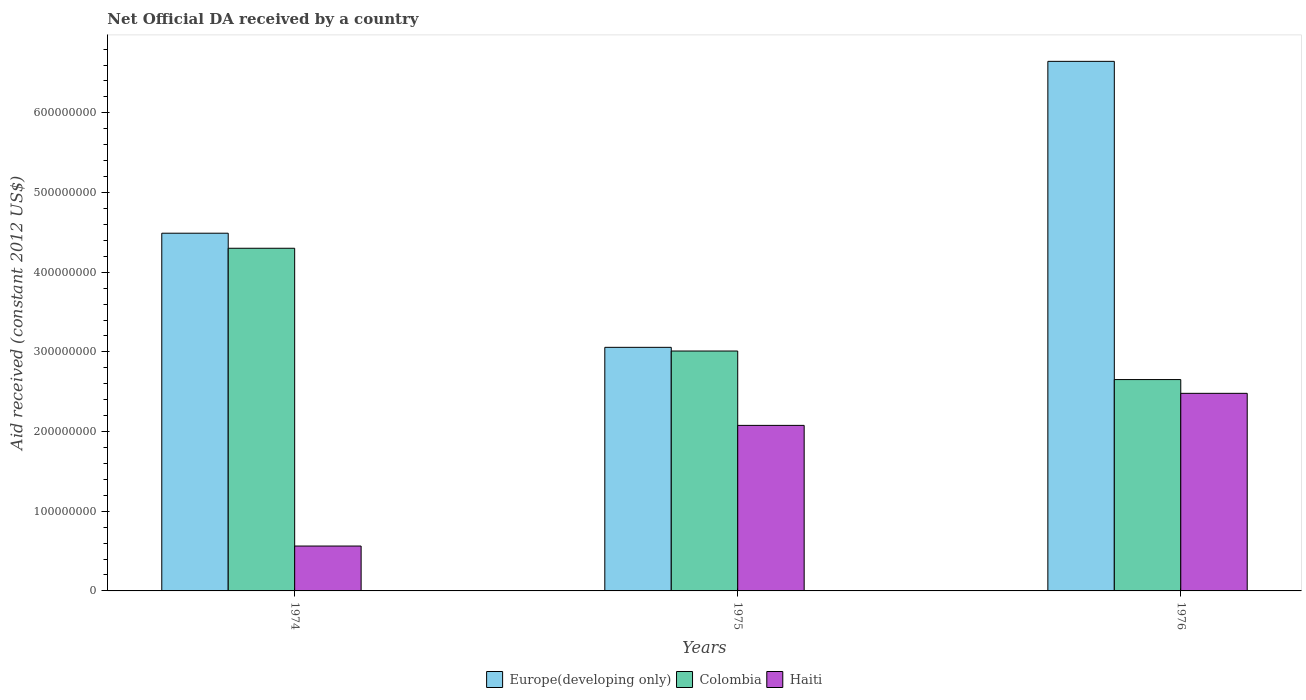Are the number of bars per tick equal to the number of legend labels?
Your answer should be compact. Yes. How many bars are there on the 3rd tick from the left?
Provide a short and direct response. 3. What is the label of the 1st group of bars from the left?
Make the answer very short. 1974. What is the net official development assistance aid received in Haiti in 1974?
Keep it short and to the point. 5.63e+07. Across all years, what is the maximum net official development assistance aid received in Europe(developing only)?
Your answer should be compact. 6.65e+08. Across all years, what is the minimum net official development assistance aid received in Europe(developing only)?
Give a very brief answer. 3.06e+08. In which year was the net official development assistance aid received in Haiti maximum?
Make the answer very short. 1976. In which year was the net official development assistance aid received in Haiti minimum?
Provide a short and direct response. 1974. What is the total net official development assistance aid received in Colombia in the graph?
Provide a short and direct response. 9.96e+08. What is the difference between the net official development assistance aid received in Colombia in 1975 and that in 1976?
Keep it short and to the point. 3.58e+07. What is the difference between the net official development assistance aid received in Europe(developing only) in 1975 and the net official development assistance aid received in Haiti in 1976?
Provide a succinct answer. 5.77e+07. What is the average net official development assistance aid received in Europe(developing only) per year?
Make the answer very short. 4.73e+08. In the year 1974, what is the difference between the net official development assistance aid received in Europe(developing only) and net official development assistance aid received in Haiti?
Your response must be concise. 3.93e+08. In how many years, is the net official development assistance aid received in Colombia greater than 180000000 US$?
Offer a very short reply. 3. What is the ratio of the net official development assistance aid received in Colombia in 1974 to that in 1976?
Make the answer very short. 1.62. Is the net official development assistance aid received in Haiti in 1974 less than that in 1976?
Offer a very short reply. Yes. What is the difference between the highest and the second highest net official development assistance aid received in Haiti?
Offer a terse response. 4.02e+07. What is the difference between the highest and the lowest net official development assistance aid received in Haiti?
Provide a short and direct response. 1.92e+08. Is the sum of the net official development assistance aid received in Haiti in 1974 and 1976 greater than the maximum net official development assistance aid received in Europe(developing only) across all years?
Offer a very short reply. No. What does the 3rd bar from the left in 1974 represents?
Give a very brief answer. Haiti. What does the 2nd bar from the right in 1975 represents?
Ensure brevity in your answer.  Colombia. Is it the case that in every year, the sum of the net official development assistance aid received in Europe(developing only) and net official development assistance aid received in Haiti is greater than the net official development assistance aid received in Colombia?
Provide a succinct answer. Yes. How many years are there in the graph?
Ensure brevity in your answer.  3. Does the graph contain any zero values?
Make the answer very short. No. How many legend labels are there?
Offer a terse response. 3. What is the title of the graph?
Keep it short and to the point. Net Official DA received by a country. What is the label or title of the Y-axis?
Ensure brevity in your answer.  Aid received (constant 2012 US$). What is the Aid received (constant 2012 US$) in Europe(developing only) in 1974?
Provide a short and direct response. 4.49e+08. What is the Aid received (constant 2012 US$) in Colombia in 1974?
Give a very brief answer. 4.30e+08. What is the Aid received (constant 2012 US$) of Haiti in 1974?
Give a very brief answer. 5.63e+07. What is the Aid received (constant 2012 US$) of Europe(developing only) in 1975?
Make the answer very short. 3.06e+08. What is the Aid received (constant 2012 US$) of Colombia in 1975?
Provide a succinct answer. 3.01e+08. What is the Aid received (constant 2012 US$) of Haiti in 1975?
Give a very brief answer. 2.08e+08. What is the Aid received (constant 2012 US$) in Europe(developing only) in 1976?
Make the answer very short. 6.65e+08. What is the Aid received (constant 2012 US$) of Colombia in 1976?
Keep it short and to the point. 2.65e+08. What is the Aid received (constant 2012 US$) in Haiti in 1976?
Provide a succinct answer. 2.48e+08. Across all years, what is the maximum Aid received (constant 2012 US$) of Europe(developing only)?
Ensure brevity in your answer.  6.65e+08. Across all years, what is the maximum Aid received (constant 2012 US$) of Colombia?
Provide a succinct answer. 4.30e+08. Across all years, what is the maximum Aid received (constant 2012 US$) in Haiti?
Your answer should be very brief. 2.48e+08. Across all years, what is the minimum Aid received (constant 2012 US$) of Europe(developing only)?
Offer a very short reply. 3.06e+08. Across all years, what is the minimum Aid received (constant 2012 US$) of Colombia?
Make the answer very short. 2.65e+08. Across all years, what is the minimum Aid received (constant 2012 US$) of Haiti?
Give a very brief answer. 5.63e+07. What is the total Aid received (constant 2012 US$) of Europe(developing only) in the graph?
Offer a terse response. 1.42e+09. What is the total Aid received (constant 2012 US$) of Colombia in the graph?
Make the answer very short. 9.96e+08. What is the total Aid received (constant 2012 US$) of Haiti in the graph?
Your answer should be very brief. 5.12e+08. What is the difference between the Aid received (constant 2012 US$) of Europe(developing only) in 1974 and that in 1975?
Offer a very short reply. 1.43e+08. What is the difference between the Aid received (constant 2012 US$) in Colombia in 1974 and that in 1975?
Provide a short and direct response. 1.29e+08. What is the difference between the Aid received (constant 2012 US$) of Haiti in 1974 and that in 1975?
Offer a very short reply. -1.51e+08. What is the difference between the Aid received (constant 2012 US$) in Europe(developing only) in 1974 and that in 1976?
Keep it short and to the point. -2.16e+08. What is the difference between the Aid received (constant 2012 US$) in Colombia in 1974 and that in 1976?
Offer a very short reply. 1.65e+08. What is the difference between the Aid received (constant 2012 US$) in Haiti in 1974 and that in 1976?
Your answer should be very brief. -1.92e+08. What is the difference between the Aid received (constant 2012 US$) of Europe(developing only) in 1975 and that in 1976?
Keep it short and to the point. -3.59e+08. What is the difference between the Aid received (constant 2012 US$) in Colombia in 1975 and that in 1976?
Your answer should be very brief. 3.58e+07. What is the difference between the Aid received (constant 2012 US$) in Haiti in 1975 and that in 1976?
Your answer should be compact. -4.02e+07. What is the difference between the Aid received (constant 2012 US$) of Europe(developing only) in 1974 and the Aid received (constant 2012 US$) of Colombia in 1975?
Offer a terse response. 1.48e+08. What is the difference between the Aid received (constant 2012 US$) in Europe(developing only) in 1974 and the Aid received (constant 2012 US$) in Haiti in 1975?
Your answer should be very brief. 2.41e+08. What is the difference between the Aid received (constant 2012 US$) in Colombia in 1974 and the Aid received (constant 2012 US$) in Haiti in 1975?
Your response must be concise. 2.22e+08. What is the difference between the Aid received (constant 2012 US$) in Europe(developing only) in 1974 and the Aid received (constant 2012 US$) in Colombia in 1976?
Provide a succinct answer. 1.84e+08. What is the difference between the Aid received (constant 2012 US$) of Europe(developing only) in 1974 and the Aid received (constant 2012 US$) of Haiti in 1976?
Give a very brief answer. 2.01e+08. What is the difference between the Aid received (constant 2012 US$) of Colombia in 1974 and the Aid received (constant 2012 US$) of Haiti in 1976?
Keep it short and to the point. 1.82e+08. What is the difference between the Aid received (constant 2012 US$) in Europe(developing only) in 1975 and the Aid received (constant 2012 US$) in Colombia in 1976?
Give a very brief answer. 4.04e+07. What is the difference between the Aid received (constant 2012 US$) of Europe(developing only) in 1975 and the Aid received (constant 2012 US$) of Haiti in 1976?
Keep it short and to the point. 5.77e+07. What is the difference between the Aid received (constant 2012 US$) of Colombia in 1975 and the Aid received (constant 2012 US$) of Haiti in 1976?
Make the answer very short. 5.31e+07. What is the average Aid received (constant 2012 US$) in Europe(developing only) per year?
Keep it short and to the point. 4.73e+08. What is the average Aid received (constant 2012 US$) in Colombia per year?
Provide a short and direct response. 3.32e+08. What is the average Aid received (constant 2012 US$) in Haiti per year?
Your answer should be compact. 1.71e+08. In the year 1974, what is the difference between the Aid received (constant 2012 US$) in Europe(developing only) and Aid received (constant 2012 US$) in Colombia?
Keep it short and to the point. 1.89e+07. In the year 1974, what is the difference between the Aid received (constant 2012 US$) of Europe(developing only) and Aid received (constant 2012 US$) of Haiti?
Your answer should be compact. 3.93e+08. In the year 1974, what is the difference between the Aid received (constant 2012 US$) of Colombia and Aid received (constant 2012 US$) of Haiti?
Offer a very short reply. 3.74e+08. In the year 1975, what is the difference between the Aid received (constant 2012 US$) in Europe(developing only) and Aid received (constant 2012 US$) in Colombia?
Give a very brief answer. 4.63e+06. In the year 1975, what is the difference between the Aid received (constant 2012 US$) in Europe(developing only) and Aid received (constant 2012 US$) in Haiti?
Your answer should be compact. 9.80e+07. In the year 1975, what is the difference between the Aid received (constant 2012 US$) in Colombia and Aid received (constant 2012 US$) in Haiti?
Make the answer very short. 9.33e+07. In the year 1976, what is the difference between the Aid received (constant 2012 US$) of Europe(developing only) and Aid received (constant 2012 US$) of Colombia?
Offer a terse response. 3.99e+08. In the year 1976, what is the difference between the Aid received (constant 2012 US$) in Europe(developing only) and Aid received (constant 2012 US$) in Haiti?
Provide a short and direct response. 4.17e+08. In the year 1976, what is the difference between the Aid received (constant 2012 US$) in Colombia and Aid received (constant 2012 US$) in Haiti?
Your response must be concise. 1.73e+07. What is the ratio of the Aid received (constant 2012 US$) of Europe(developing only) in 1974 to that in 1975?
Offer a very short reply. 1.47. What is the ratio of the Aid received (constant 2012 US$) in Colombia in 1974 to that in 1975?
Give a very brief answer. 1.43. What is the ratio of the Aid received (constant 2012 US$) of Haiti in 1974 to that in 1975?
Provide a succinct answer. 0.27. What is the ratio of the Aid received (constant 2012 US$) of Europe(developing only) in 1974 to that in 1976?
Offer a terse response. 0.68. What is the ratio of the Aid received (constant 2012 US$) of Colombia in 1974 to that in 1976?
Your answer should be compact. 1.62. What is the ratio of the Aid received (constant 2012 US$) in Haiti in 1974 to that in 1976?
Offer a very short reply. 0.23. What is the ratio of the Aid received (constant 2012 US$) of Europe(developing only) in 1975 to that in 1976?
Provide a succinct answer. 0.46. What is the ratio of the Aid received (constant 2012 US$) in Colombia in 1975 to that in 1976?
Offer a terse response. 1.14. What is the ratio of the Aid received (constant 2012 US$) in Haiti in 1975 to that in 1976?
Your answer should be compact. 0.84. What is the difference between the highest and the second highest Aid received (constant 2012 US$) in Europe(developing only)?
Provide a succinct answer. 2.16e+08. What is the difference between the highest and the second highest Aid received (constant 2012 US$) in Colombia?
Offer a very short reply. 1.29e+08. What is the difference between the highest and the second highest Aid received (constant 2012 US$) in Haiti?
Offer a terse response. 4.02e+07. What is the difference between the highest and the lowest Aid received (constant 2012 US$) in Europe(developing only)?
Make the answer very short. 3.59e+08. What is the difference between the highest and the lowest Aid received (constant 2012 US$) in Colombia?
Offer a terse response. 1.65e+08. What is the difference between the highest and the lowest Aid received (constant 2012 US$) in Haiti?
Keep it short and to the point. 1.92e+08. 